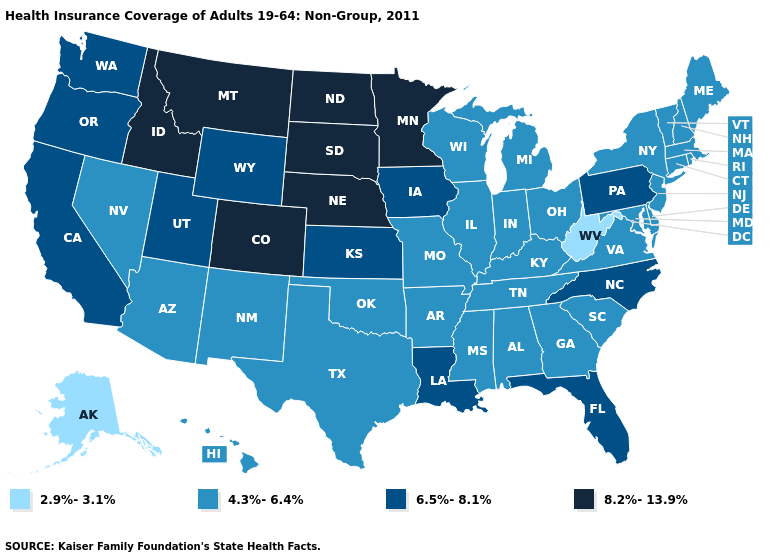Which states have the highest value in the USA?
Concise answer only. Colorado, Idaho, Minnesota, Montana, Nebraska, North Dakota, South Dakota. What is the value of Virginia?
Give a very brief answer. 4.3%-6.4%. What is the value of Tennessee?
Write a very short answer. 4.3%-6.4%. Name the states that have a value in the range 8.2%-13.9%?
Short answer required. Colorado, Idaho, Minnesota, Montana, Nebraska, North Dakota, South Dakota. Which states have the lowest value in the USA?
Quick response, please. Alaska, West Virginia. Among the states that border Minnesota , which have the lowest value?
Short answer required. Wisconsin. What is the highest value in the West ?
Be succinct. 8.2%-13.9%. What is the lowest value in the USA?
Quick response, please. 2.9%-3.1%. Name the states that have a value in the range 6.5%-8.1%?
Concise answer only. California, Florida, Iowa, Kansas, Louisiana, North Carolina, Oregon, Pennsylvania, Utah, Washington, Wyoming. What is the lowest value in the USA?
Write a very short answer. 2.9%-3.1%. What is the value of South Carolina?
Be succinct. 4.3%-6.4%. Does North Carolina have the highest value in the South?
Write a very short answer. Yes. Does Nebraska have the lowest value in the USA?
Answer briefly. No. What is the lowest value in the USA?
Keep it brief. 2.9%-3.1%. Does West Virginia have the lowest value in the USA?
Answer briefly. Yes. 